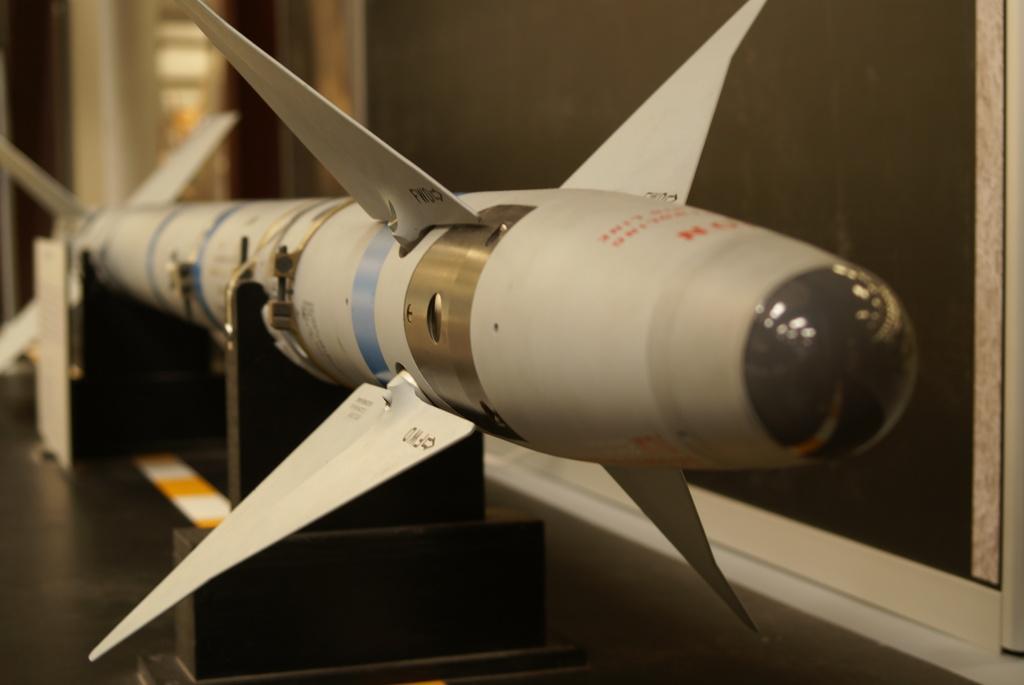In one or two sentences, can you explain what this image depicts? In this image we can see a missile placed on stands. In the background, we can see the wall. 